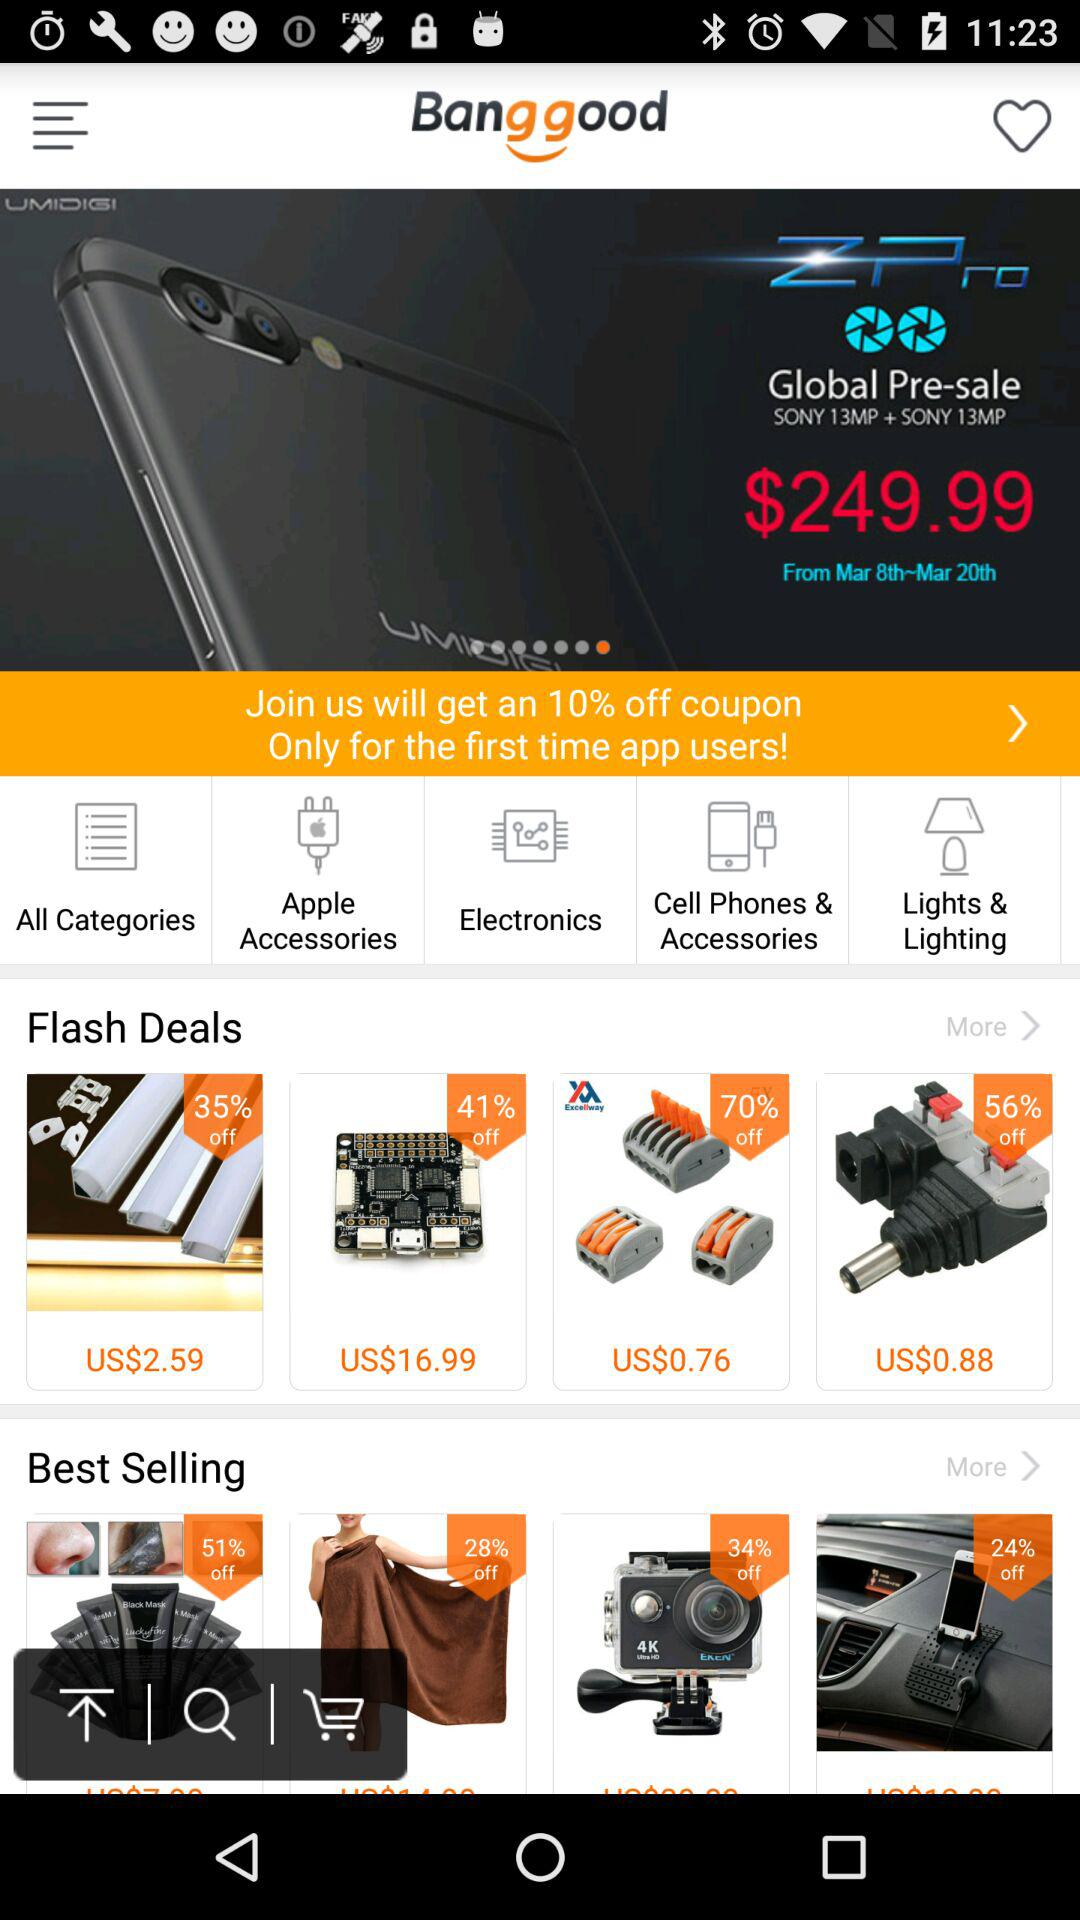How much off do we get by coupon on our first time using the app? You get 10% off. 